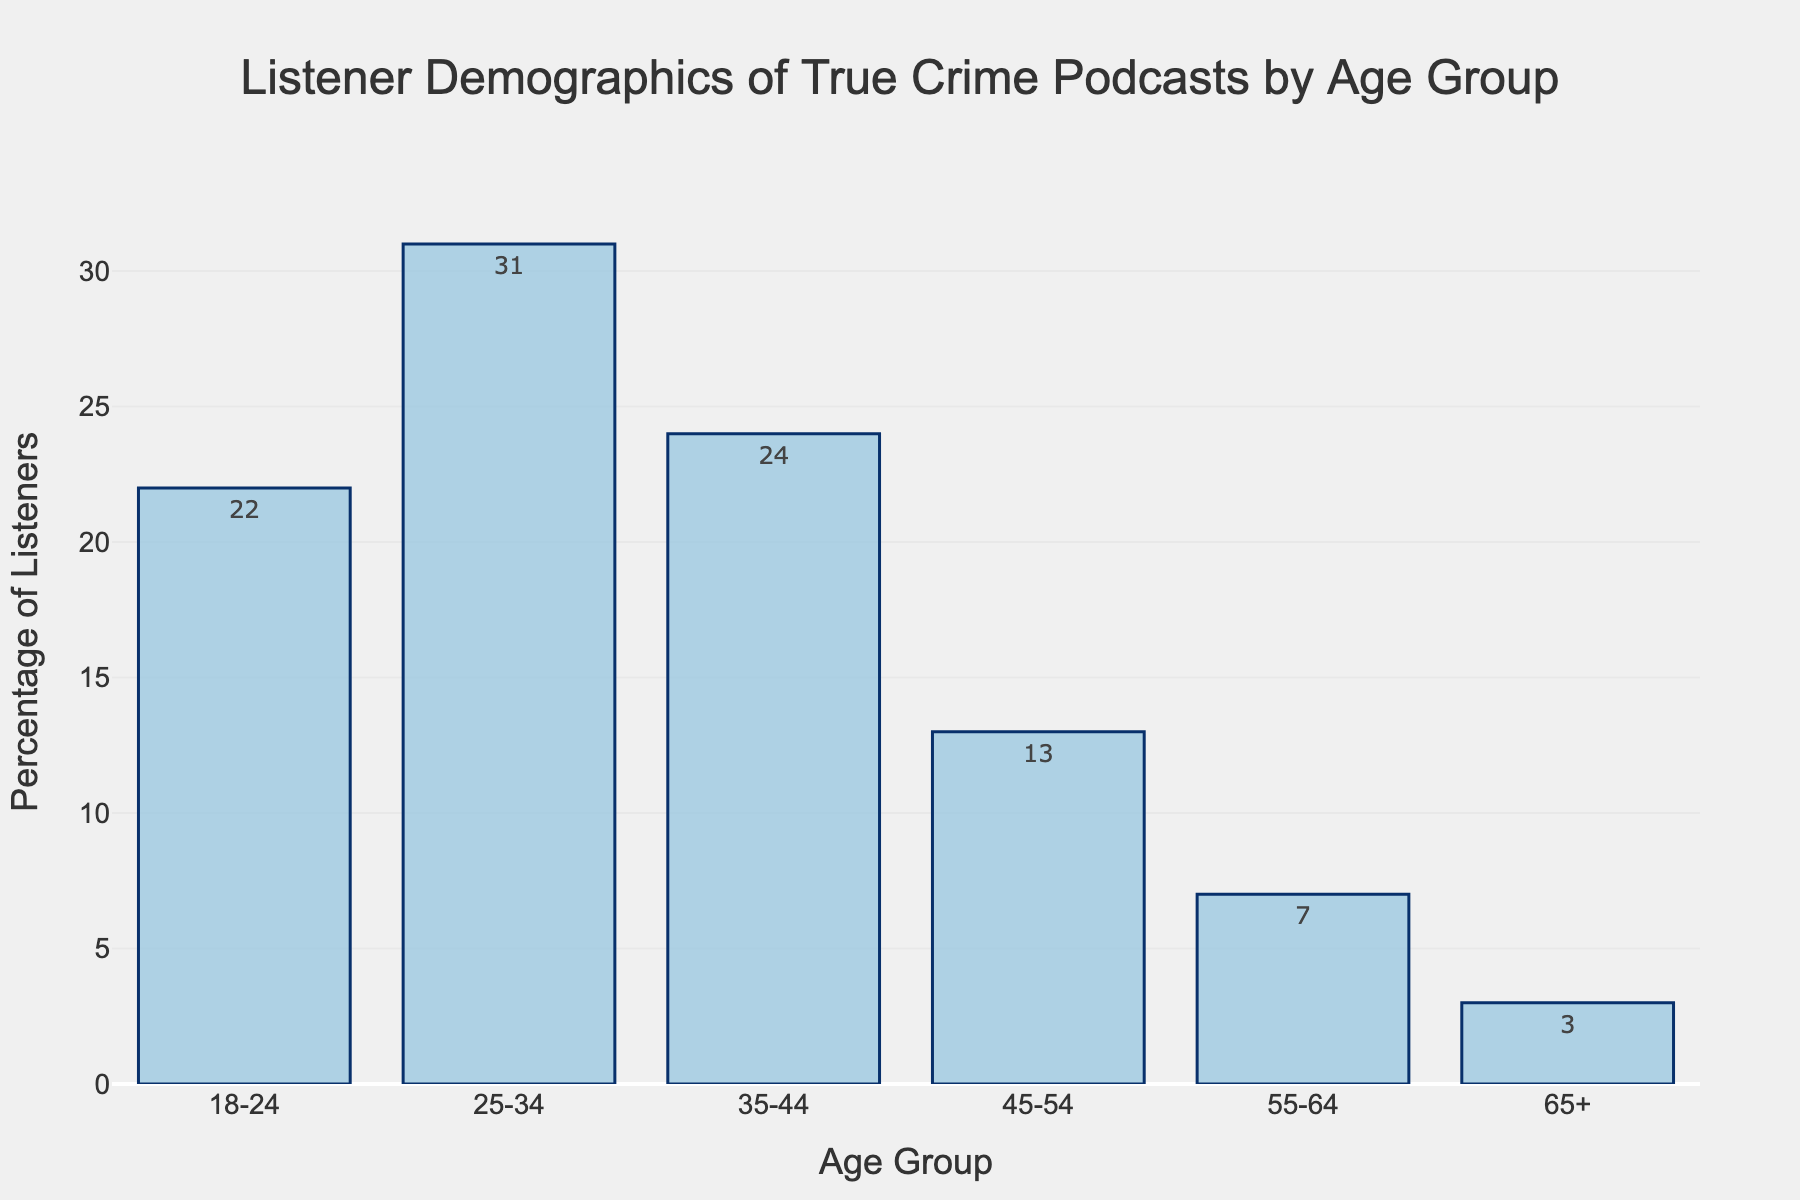Which age group has the highest percentage of listeners for true crime podcasts? The bar for the 25-34 age group is the tallest, indicating it has the highest percentage of listeners.
Answer: 25-34 How does the percentage of listeners aged 35-44 compare to those aged 45-54? The bar for the 35-44 age group is taller than the bar for the 45-54 age group. The 35-44 group has 24% while the 45-54 group has 13%.
Answer: 35-44 has a higher percentage What is the combined percentage of listeners for the age groups 55-64 and 65+? The percentage of listeners for 55-64 is 7% and for 65+ it is 3%. Adding these together gives 7% + 3% = 10%.
Answer: 10% How much more popular are true crime podcasts among listeners aged 25-34 than those aged 55-64? Subtract the 55-64 percentage (7%) from the 25-34 percentage (31%): 31% - 7% = 24%.
Answer: 24% more popular Which age group has the least percentage of listeners, and what is its value? The bar for the 65+ age group is the shortest, indicating it has the lowest percentage of listeners at 3%.
Answer: 65+, 3% What is the average percentage of listeners across all age groups? Sum all percentages (22% + 31% + 24% + 13% + 7% + 3% = 100%) and divide by the number of groups (6): 100% / 6 ≈ 16.67%.
Answer: 16.67% How does the percentage of listeners in the 18-24 age group compare to the 35-44 age group? The percentage for 18-24 is 22% and for 35-44 is 24%. The 35-44 age group has a slightly higher percentage by a difference of 2%.
Answer: 35-44 is 2% higher Between which two consecutive age groups is the largest drop in listener percentage observed? The largest drop occurs between 35-44 (24%) and 45-54 (13%), with a difference of 24% - 13% = 11%.
Answer: 35-44 and 45-54 What is the percentage difference between the youngest (18-24) and the oldest (65+) age groups? Subtract the percentage for 65+ (3%) from 18-24 (22%): 22% - 3% = 19%.
Answer: 19% 